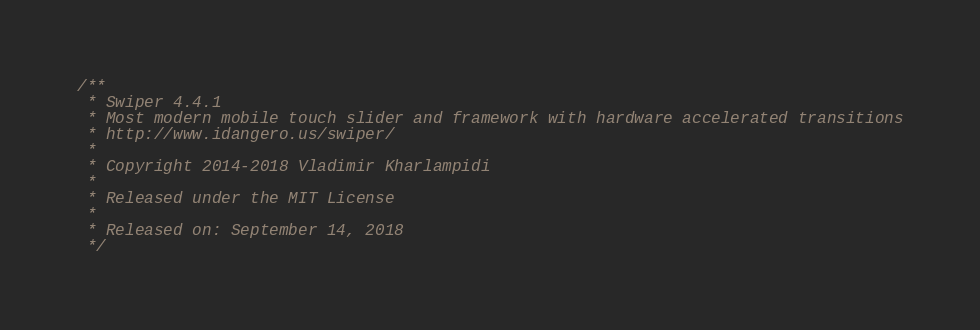Convert code to text. <code><loc_0><loc_0><loc_500><loc_500><_CSS_>/**
 * Swiper 4.4.1
 * Most modern mobile touch slider and framework with hardware accelerated transitions
 * http://www.idangero.us/swiper/
 *
 * Copyright 2014-2018 Vladimir Kharlampidi
 *
 * Released under the MIT License
 *
 * Released on: September 14, 2018
 */</code> 